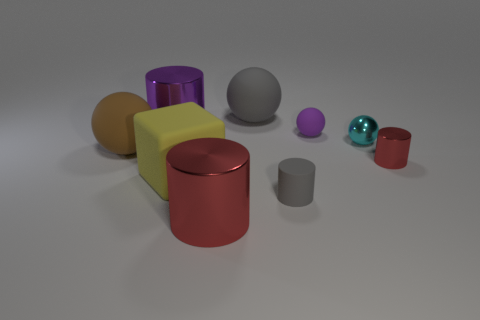Imagine these objects in a playground setting. Which might interest children the most? In a playground setting, children might be most drawn to the yellow cube because of its size and bright color. It resembles a large toy block that children can climb on or play around. The vivid purple and teal colors of the cylinders and sphere may also attract attention, encouraging imaginative play. 